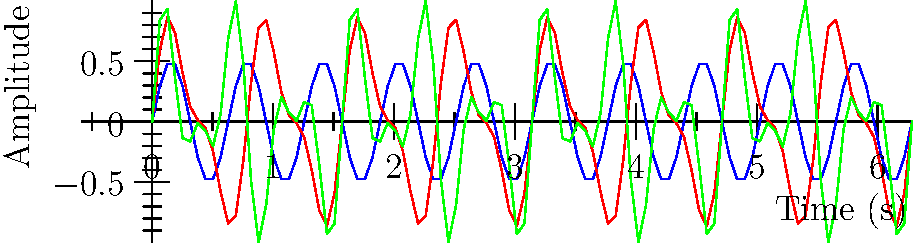Analyze the waveform diagrams representing rhythmic patterns from different eras of Finnish music. Which era shows the most complex and varied rhythmic structure, and how does this reflect the evolution of Finnish musical composition? To answer this question, we need to examine the waveforms for each era:

1. Early Finnish Folk Music (blue line):
   - Simple, repetitive pattern
   - Regular sine wave with constant frequency and amplitude
   - Represents basic, consistent rhythms common in traditional folk music

2. Sibelius Era (red line):
   - More complex pattern than folk music
   - Combines two sine waves of different frequencies
   - Reflects the more sophisticated compositional techniques of the late Romantic period

3. Contemporary Finnish Music (green line):
   - Most complex and varied pattern
   - Combines multiple sine waves of different frequencies and amplitudes
   - Irregular peaks and troughs, representing diverse rhythmic structures

The evolution of Finnish musical composition is evident in the increasing complexity of the waveforms:
- From simple, repetitive patterns in folk music
- To more flowing, expressive rhythms in the Sibelius era
- To highly varied and complex rhythms in contemporary music

This progression mirrors the development of Finnish music from traditional forms to more experimental and diverse styles in the modern era.
Answer: Contemporary Finnish music, showing most complex waveform with irregular patterns. 